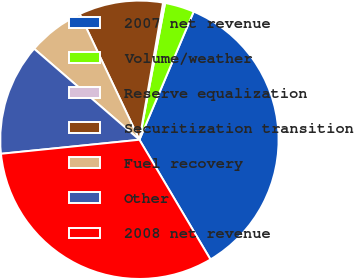<chart> <loc_0><loc_0><loc_500><loc_500><pie_chart><fcel>2007 net revenue<fcel>Volume/weather<fcel>Reserve equalization<fcel>Securitization transition<fcel>Fuel recovery<fcel>Other<fcel>2008 net revenue<nl><fcel>35.1%<fcel>3.42%<fcel>0.24%<fcel>9.77%<fcel>6.6%<fcel>12.95%<fcel>31.92%<nl></chart> 